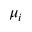Convert formula to latex. <formula><loc_0><loc_0><loc_500><loc_500>\mu _ { i }</formula> 